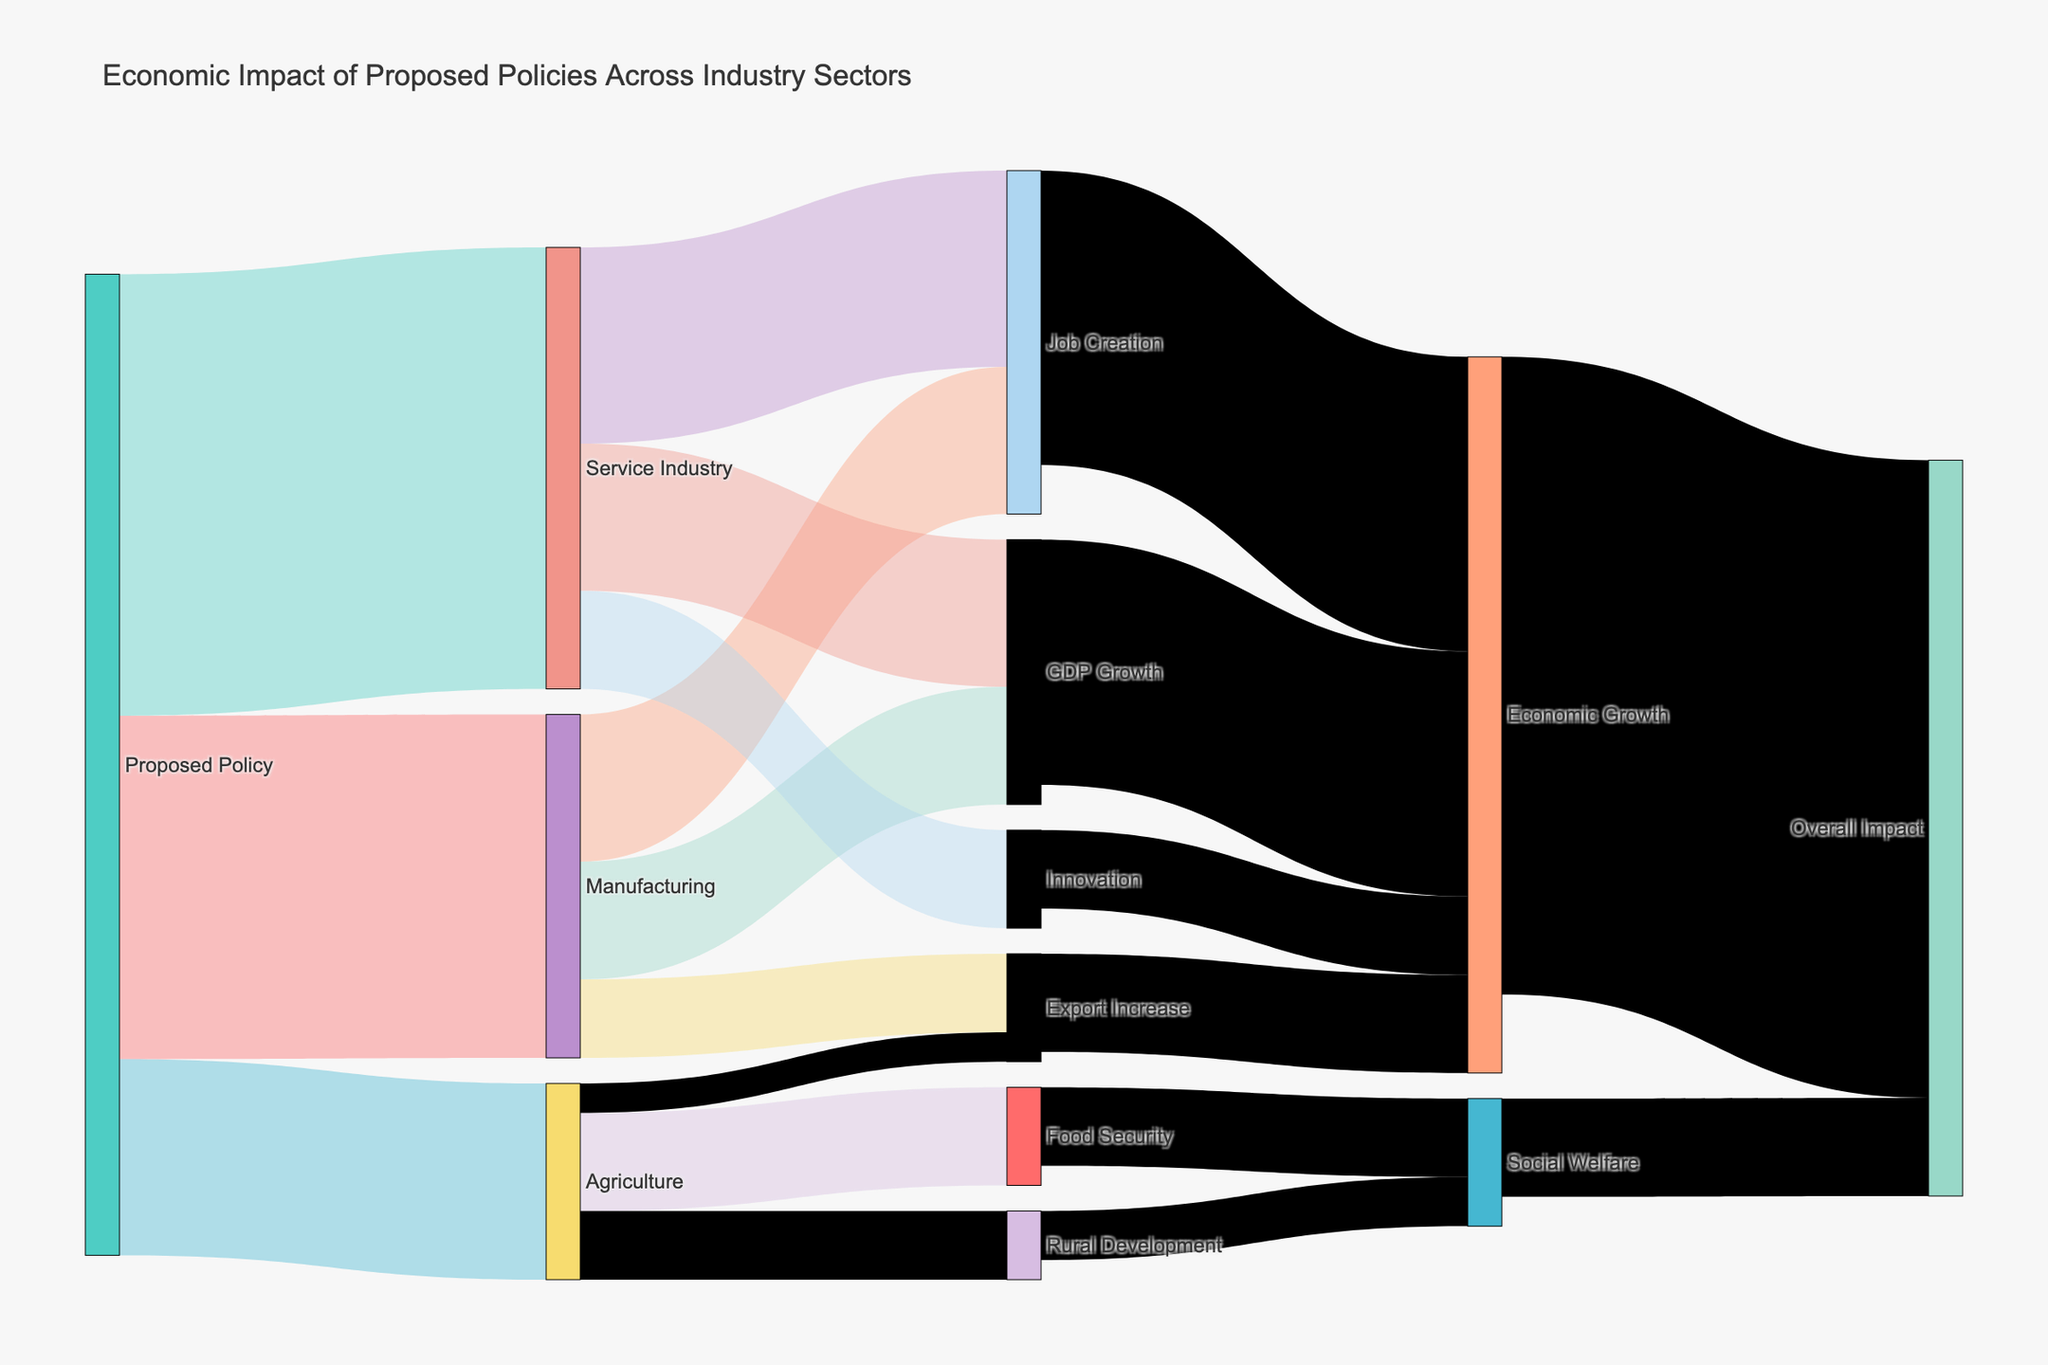What's the largest industry sector affected by the proposed policy? From the initial nodes connected to "Proposed Policy," we see that the Service Industry has the largest value at 45, followed by Manufacturing at 35 and Agriculture at 20. Hence, Service Industry is the largest affected sector.
Answer: Service Industry Among the impacts within the Manufacturing sector, which has the highest value? Within the Manufacturing sector, it splits into Job Creation (15), GDP Growth (12), and Export Increase (8). Thus, Job Creation has the highest value at 15.
Answer: Job Creation What is the total value contributed to Economic Growth from the proposed policy? Economic Growth is reached through multiple paths: Job Creation (30), GDP Growth (25), Export Increase (10), and Innovation (8). Summing these values, 30 + 25 + 10 + 8 = 73 (but note that GDP Growth directly contributes only 25+10+8 = 43). Considering different pathways without double-counting, Manufacturing contributes 12 directly, and the cumulative sums maintain 43 and 30.
Answer: 65 Compare the impacts of Service Industry on Job Creation and Innovation. Which is higher? Service Industry impacts Job Creation with a value of 20 and Innovation with a value of 10. Thus, Job Creation is the higher impact.
Answer: Job Creation How does Rural Development influence the overall impact compared to Food Security? Rural Development contributes 5 to Social Welfare, while Food Security contributes 8. Since Social Welfare's total contribution to Overall Impact is 10, Rural Development has a smaller influence compared to Food Security.
Answer: Food Security Which sector has the lowest direct contribution to Export Increase, Manufacturing or Agriculture? Manufacturing contributes 8 to Export Increase, whereas Agriculture contributes 3 to Export Increase. Thus, Agriculture has the lower direct contribution.
Answer: Agriculture What is the total value of impacts directly connected to the Service Industry? Service Industry's impacts include Job Creation (20), GDP Growth (15), and Innovation (10). Summing these values, 20 + 15 + 10 = 45.
Answer: 45 How does the overall impact of Economic Growth compare to Social Welfare? The overall impact of Economic Growth is 65, while Social Welfare is 10. Hence, Economic Growth has a significantly higher overall impact.
Answer: Economic Growth 